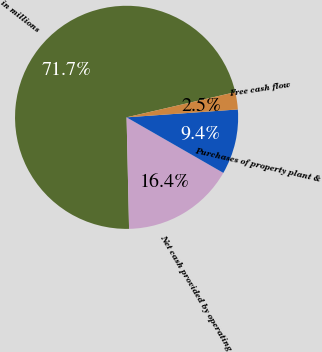<chart> <loc_0><loc_0><loc_500><loc_500><pie_chart><fcel>in millions<fcel>Net cash provided by operating<fcel>Purchases of property plant &<fcel>Free cash flow<nl><fcel>71.73%<fcel>16.35%<fcel>9.42%<fcel>2.5%<nl></chart> 